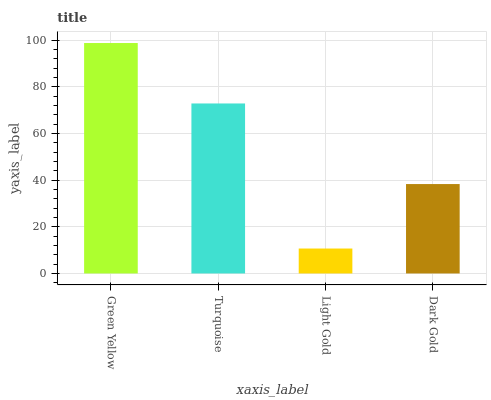Is Light Gold the minimum?
Answer yes or no. Yes. Is Green Yellow the maximum?
Answer yes or no. Yes. Is Turquoise the minimum?
Answer yes or no. No. Is Turquoise the maximum?
Answer yes or no. No. Is Green Yellow greater than Turquoise?
Answer yes or no. Yes. Is Turquoise less than Green Yellow?
Answer yes or no. Yes. Is Turquoise greater than Green Yellow?
Answer yes or no. No. Is Green Yellow less than Turquoise?
Answer yes or no. No. Is Turquoise the high median?
Answer yes or no. Yes. Is Dark Gold the low median?
Answer yes or no. Yes. Is Light Gold the high median?
Answer yes or no. No. Is Light Gold the low median?
Answer yes or no. No. 